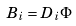Convert formula to latex. <formula><loc_0><loc_0><loc_500><loc_500>B _ { i } = D _ { i } \Phi</formula> 